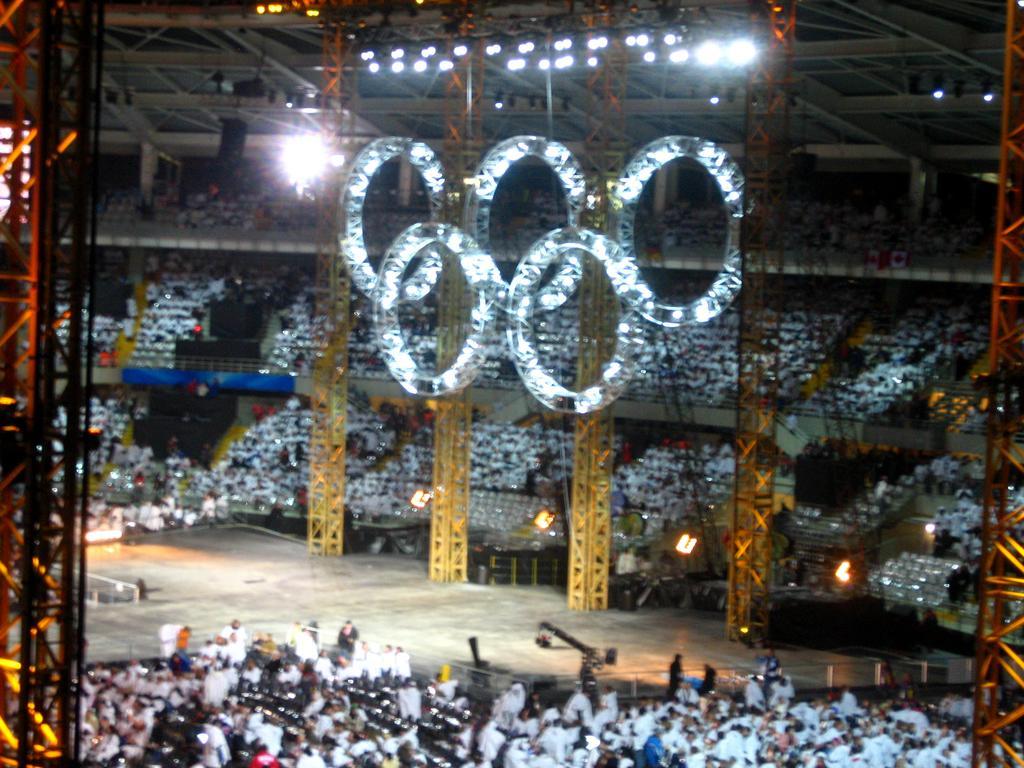Describe this image in one or two sentences. In this image there is an auditorium, in that there are people sitting on chairs and there are lights. 